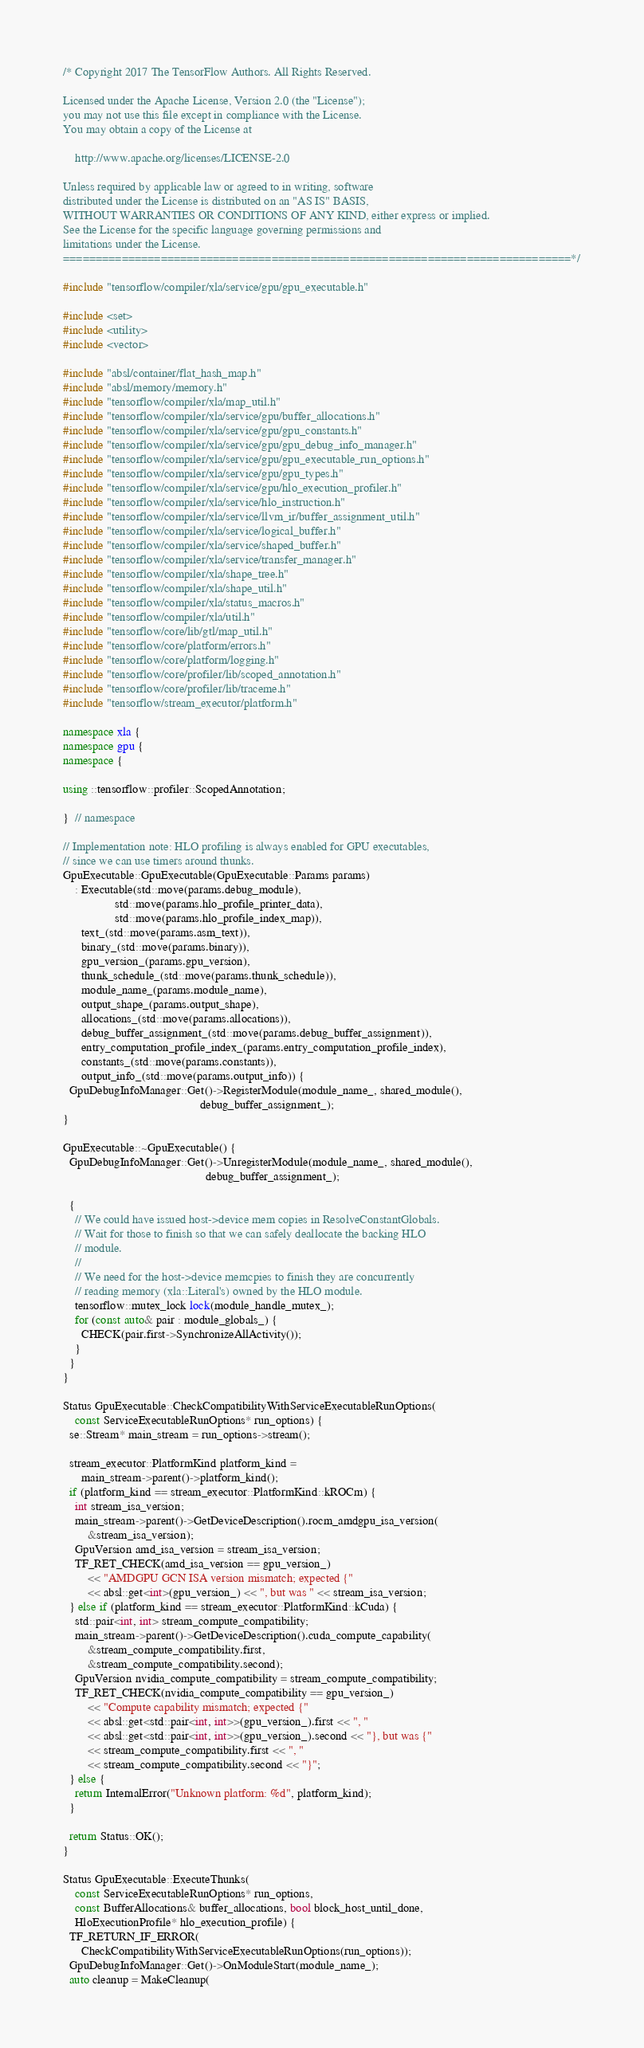<code> <loc_0><loc_0><loc_500><loc_500><_C++_>/* Copyright 2017 The TensorFlow Authors. All Rights Reserved.

Licensed under the Apache License, Version 2.0 (the "License");
you may not use this file except in compliance with the License.
You may obtain a copy of the License at

    http://www.apache.org/licenses/LICENSE-2.0

Unless required by applicable law or agreed to in writing, software
distributed under the License is distributed on an "AS IS" BASIS,
WITHOUT WARRANTIES OR CONDITIONS OF ANY KIND, either express or implied.
See the License for the specific language governing permissions and
limitations under the License.
==============================================================================*/

#include "tensorflow/compiler/xla/service/gpu/gpu_executable.h"

#include <set>
#include <utility>
#include <vector>

#include "absl/container/flat_hash_map.h"
#include "absl/memory/memory.h"
#include "tensorflow/compiler/xla/map_util.h"
#include "tensorflow/compiler/xla/service/gpu/buffer_allocations.h"
#include "tensorflow/compiler/xla/service/gpu/gpu_constants.h"
#include "tensorflow/compiler/xla/service/gpu/gpu_debug_info_manager.h"
#include "tensorflow/compiler/xla/service/gpu/gpu_executable_run_options.h"
#include "tensorflow/compiler/xla/service/gpu/gpu_types.h"
#include "tensorflow/compiler/xla/service/gpu/hlo_execution_profiler.h"
#include "tensorflow/compiler/xla/service/hlo_instruction.h"
#include "tensorflow/compiler/xla/service/llvm_ir/buffer_assignment_util.h"
#include "tensorflow/compiler/xla/service/logical_buffer.h"
#include "tensorflow/compiler/xla/service/shaped_buffer.h"
#include "tensorflow/compiler/xla/service/transfer_manager.h"
#include "tensorflow/compiler/xla/shape_tree.h"
#include "tensorflow/compiler/xla/shape_util.h"
#include "tensorflow/compiler/xla/status_macros.h"
#include "tensorflow/compiler/xla/util.h"
#include "tensorflow/core/lib/gtl/map_util.h"
#include "tensorflow/core/platform/errors.h"
#include "tensorflow/core/platform/logging.h"
#include "tensorflow/core/profiler/lib/scoped_annotation.h"
#include "tensorflow/core/profiler/lib/traceme.h"
#include "tensorflow/stream_executor/platform.h"

namespace xla {
namespace gpu {
namespace {

using ::tensorflow::profiler::ScopedAnnotation;

}  // namespace

// Implementation note: HLO profiling is always enabled for GPU executables,
// since we can use timers around thunks.
GpuExecutable::GpuExecutable(GpuExecutable::Params params)
    : Executable(std::move(params.debug_module),
                 std::move(params.hlo_profile_printer_data),
                 std::move(params.hlo_profile_index_map)),
      text_(std::move(params.asm_text)),
      binary_(std::move(params.binary)),
      gpu_version_(params.gpu_version),
      thunk_schedule_(std::move(params.thunk_schedule)),
      module_name_(params.module_name),
      output_shape_(params.output_shape),
      allocations_(std::move(params.allocations)),
      debug_buffer_assignment_(std::move(params.debug_buffer_assignment)),
      entry_computation_profile_index_(params.entry_computation_profile_index),
      constants_(std::move(params.constants)),
      output_info_(std::move(params.output_info)) {
  GpuDebugInfoManager::Get()->RegisterModule(module_name_, shared_module(),
                                             debug_buffer_assignment_);
}

GpuExecutable::~GpuExecutable() {
  GpuDebugInfoManager::Get()->UnregisterModule(module_name_, shared_module(),
                                               debug_buffer_assignment_);

  {
    // We could have issued host->device mem copies in ResolveConstantGlobals.
    // Wait for those to finish so that we can safely deallocate the backing HLO
    // module.
    //
    // We need for the host->device memcpies to finish they are concurrently
    // reading memory (xla::Literal's) owned by the HLO module.
    tensorflow::mutex_lock lock(module_handle_mutex_);
    for (const auto& pair : module_globals_) {
      CHECK(pair.first->SynchronizeAllActivity());
    }
  }
}

Status GpuExecutable::CheckCompatibilityWithServiceExecutableRunOptions(
    const ServiceExecutableRunOptions* run_options) {
  se::Stream* main_stream = run_options->stream();

  stream_executor::PlatformKind platform_kind =
      main_stream->parent()->platform_kind();
  if (platform_kind == stream_executor::PlatformKind::kROCm) {
    int stream_isa_version;
    main_stream->parent()->GetDeviceDescription().rocm_amdgpu_isa_version(
        &stream_isa_version);
    GpuVersion amd_isa_version = stream_isa_version;
    TF_RET_CHECK(amd_isa_version == gpu_version_)
        << "AMDGPU GCN ISA version mismatch; expected {"
        << absl::get<int>(gpu_version_) << ", but was " << stream_isa_version;
  } else if (platform_kind == stream_executor::PlatformKind::kCuda) {
    std::pair<int, int> stream_compute_compatibility;
    main_stream->parent()->GetDeviceDescription().cuda_compute_capability(
        &stream_compute_compatibility.first,
        &stream_compute_compatibility.second);
    GpuVersion nvidia_compute_compatibility = stream_compute_compatibility;
    TF_RET_CHECK(nvidia_compute_compatibility == gpu_version_)
        << "Compute capability mismatch; expected {"
        << absl::get<std::pair<int, int>>(gpu_version_).first << ", "
        << absl::get<std::pair<int, int>>(gpu_version_).second << "}, but was {"
        << stream_compute_compatibility.first << ", "
        << stream_compute_compatibility.second << "}";
  } else {
    return InternalError("Unknown platform: %d", platform_kind);
  }

  return Status::OK();
}

Status GpuExecutable::ExecuteThunks(
    const ServiceExecutableRunOptions* run_options,
    const BufferAllocations& buffer_allocations, bool block_host_until_done,
    HloExecutionProfile* hlo_execution_profile) {
  TF_RETURN_IF_ERROR(
      CheckCompatibilityWithServiceExecutableRunOptions(run_options));
  GpuDebugInfoManager::Get()->OnModuleStart(module_name_);
  auto cleanup = MakeCleanup(</code> 